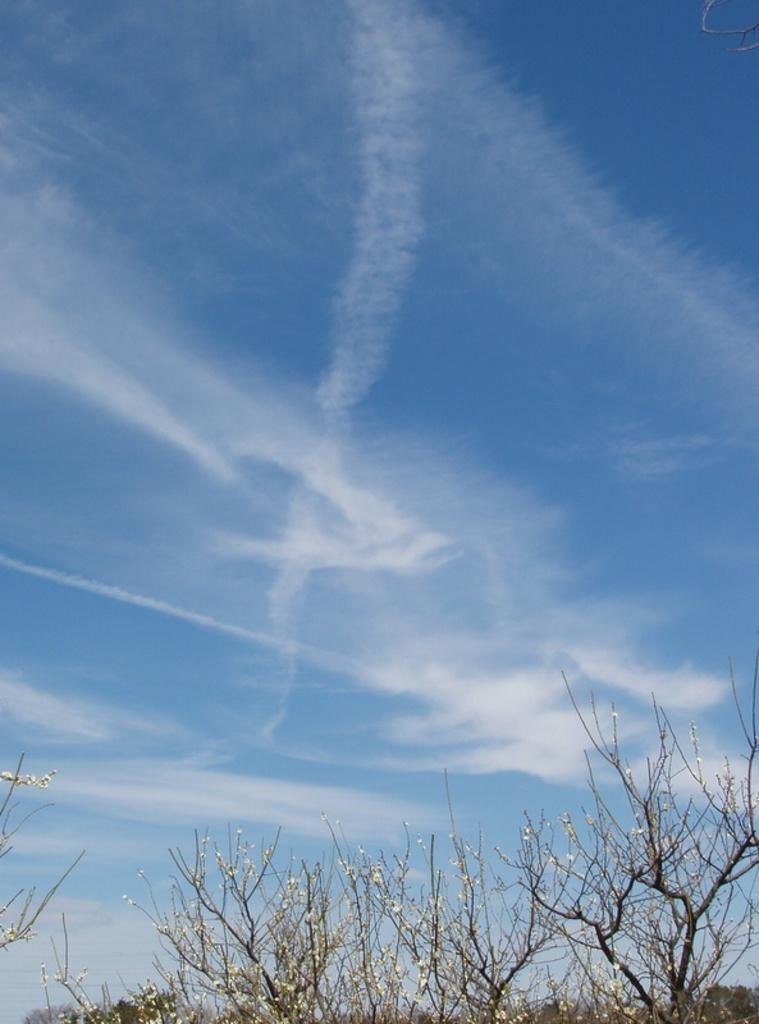What type of vegetation is present on the ground in the image? There are plants on the ground in the image. Where are the plants located in relation to the picture? The plants are in the bottom of the picture. What can be seen in the sky in the background of the image? There are clouds in the sky in the background of the image. What shape is the queen's crown in the image? There is no queen or crown present in the image; it features plants on the ground and clouds in the sky. 